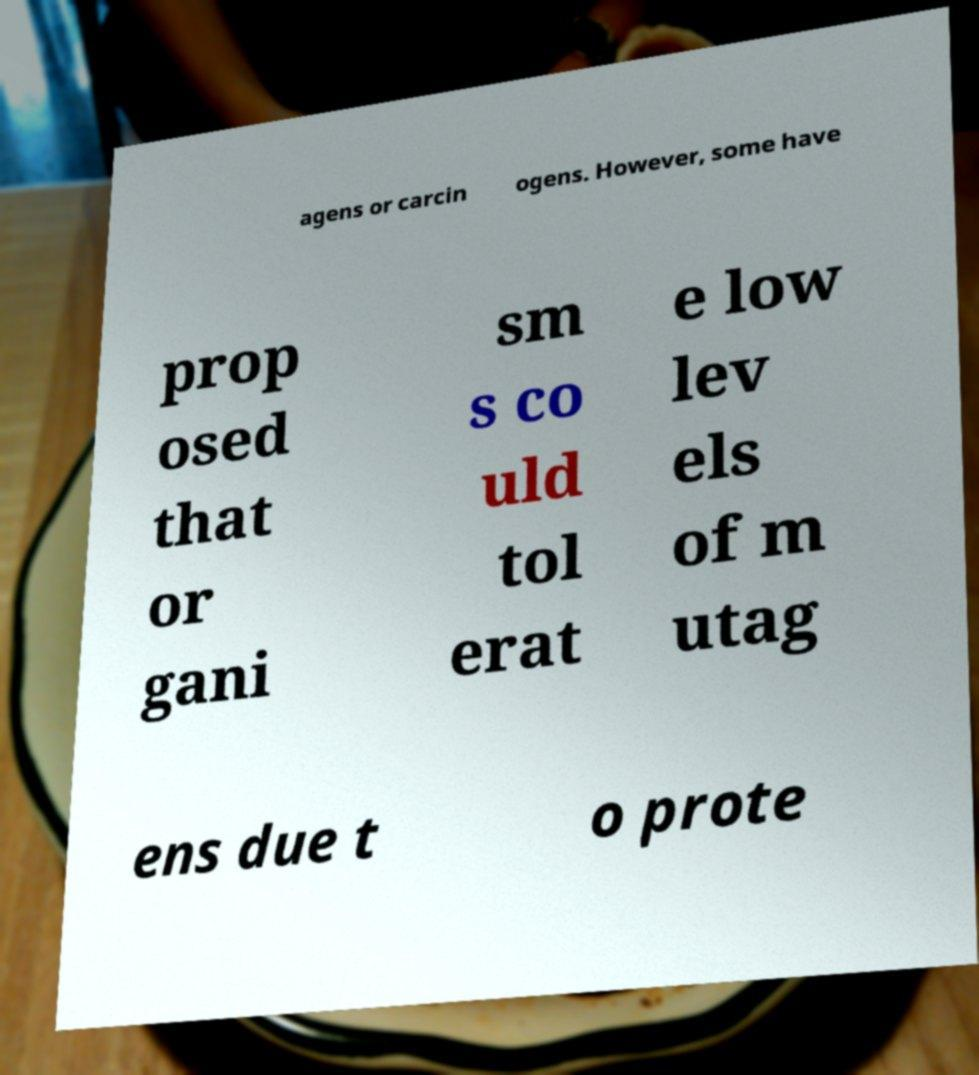Please read and relay the text visible in this image. What does it say? agens or carcin ogens. However, some have prop osed that or gani sm s co uld tol erat e low lev els of m utag ens due t o prote 